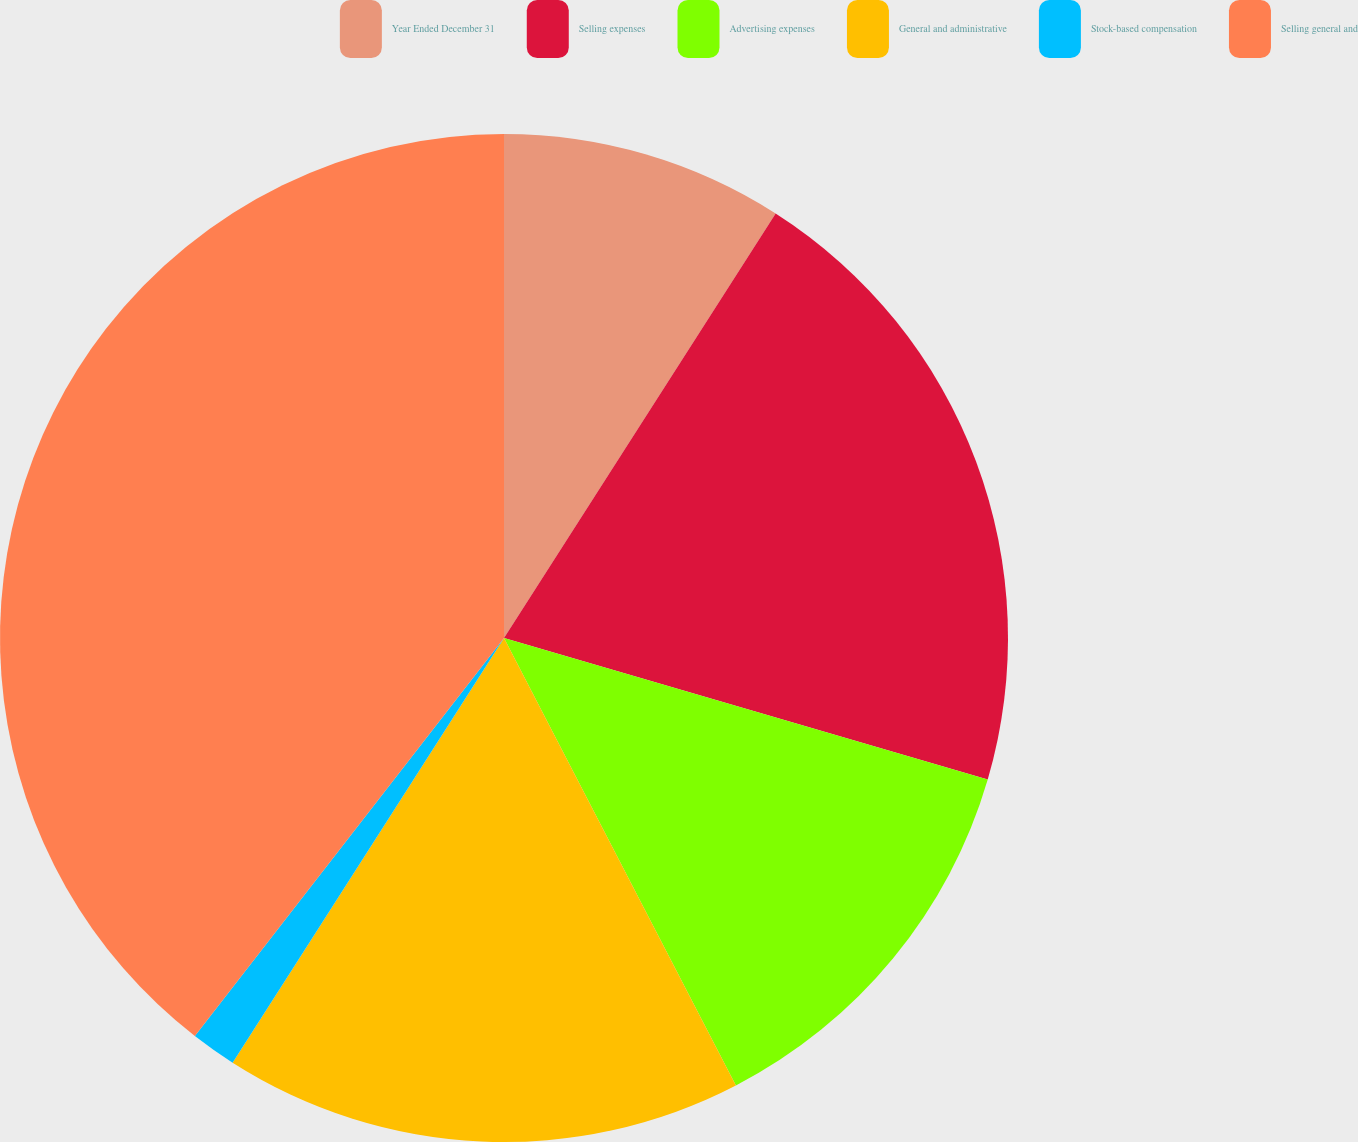<chart> <loc_0><loc_0><loc_500><loc_500><pie_chart><fcel>Year Ended December 31<fcel>Selling expenses<fcel>Advertising expenses<fcel>General and administrative<fcel>Stock-based compensation<fcel>Selling general and<nl><fcel>9.06%<fcel>20.47%<fcel>12.86%<fcel>16.66%<fcel>1.46%<fcel>39.49%<nl></chart> 